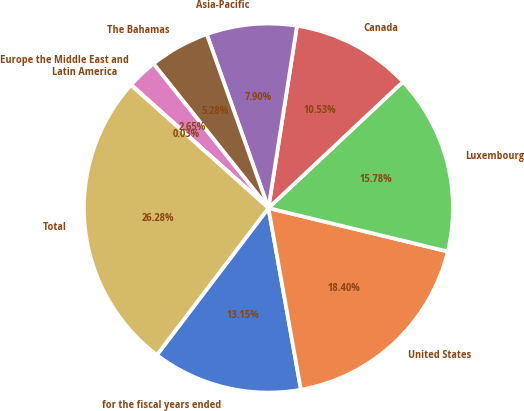Convert chart to OTSL. <chart><loc_0><loc_0><loc_500><loc_500><pie_chart><fcel>for the fiscal years ended<fcel>United States<fcel>Luxembourg<fcel>Canada<fcel>Asia-Pacific<fcel>The Bahamas<fcel>Europe the Middle East and<fcel>Latin America<fcel>Total<nl><fcel>13.15%<fcel>18.4%<fcel>15.78%<fcel>10.53%<fcel>7.9%<fcel>5.28%<fcel>2.65%<fcel>0.03%<fcel>26.28%<nl></chart> 